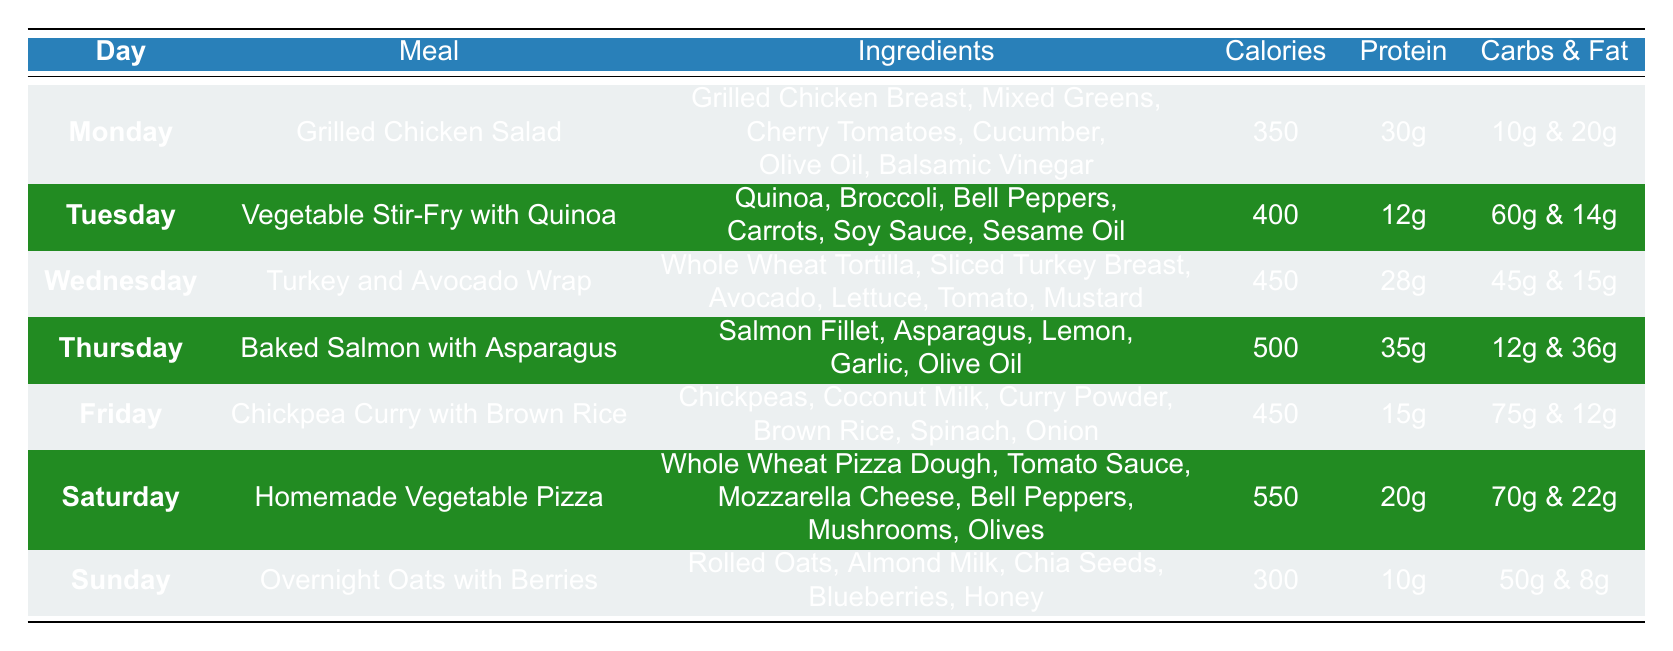What meal has the highest calorie count? By examining the "Calories" column for each meal, I can see that "Homemade Vegetable Pizza" on Saturday has the highest calorie count at 550.
Answer: Homemade Vegetable Pizza Which day features a meal that is exactly 450 calories? Looking through the "Calories" column, both "Turkey and Avocado Wrap" on Wednesday and "Chickpea Curry with Brown Rice" on Friday are listed at exactly 450 calories.
Answer: Wednesday and Friday What is the total protein content for the meals on Tuesday and Thursday combined? The protein content for Tuesday's "Vegetable Stir-Fry with Quinoa" is 12g and for Thursday's "Baked Salmon with Asparagus" is 35g. Adding these together gives 12g + 35g = 47g.
Answer: 47g Is there a meal that contains more than 30g of protein? Checking the "Protein" column, both "Baked Salmon with Asparagus" on Thursday (35g) and "Grilled Chicken Salad" on Monday (30g) meet this criterion. Since we are looking for more than 30g, "Baked Salmon with Asparagus" is the answer.
Answer: Yes What is the average calorie count for all meals listed in the table? To find the average, I need to sum up all the calorie counts (350 + 400 + 450 + 500 + 450 + 550 + 300 = 3000) and divide by the number of meals, which is 7. Thus, 3000 calories / 7 meals = 428.57, rounded to the nearest whole number gives 429.
Answer: 429 What are the total carbs for Friday's meal compared to Wednesday's meal? On Friday, the "Chickpea Curry with Brown Rice" has 75g of carbs, and on Wednesday, the "Turkey and Avocado Wrap" has 45g of carbs. Therefore, the total carbs for Friday's meal exceed Wednesday's by 30g (75g - 45g = 30g).
Answer: 30g Which meals include olive oil? By reviewing the ingredients listed, both "Grilled Chicken Salad" on Monday and "Baked Salmon with Asparagus" on Thursday include olive oil.
Answer: Monday and Thursday Which day features a meal with the least amount of calories? Looking at the "Calories" column, I find that "Overnight Oats with Berries" on Sunday has the least amount of calories at 300.
Answer: Sunday 